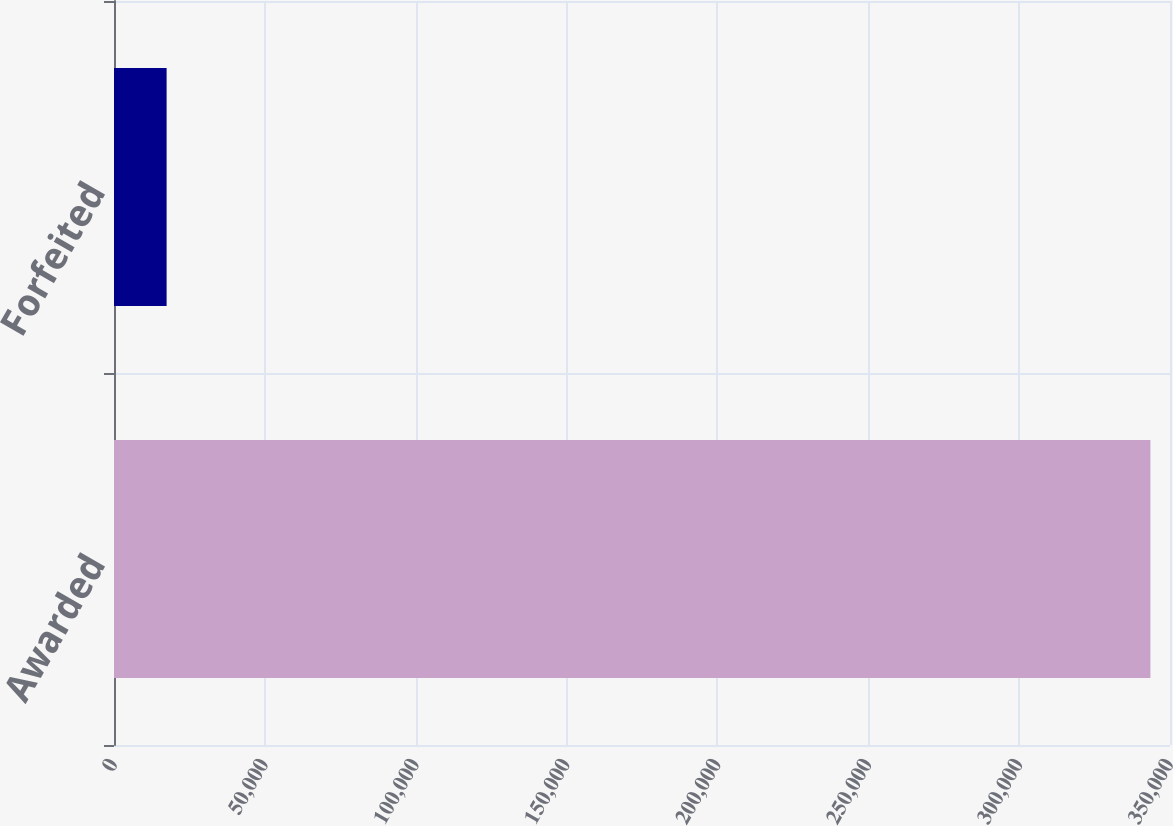Convert chart to OTSL. <chart><loc_0><loc_0><loc_500><loc_500><bar_chart><fcel>Awarded<fcel>Forfeited<nl><fcel>343500<fcel>17438<nl></chart> 